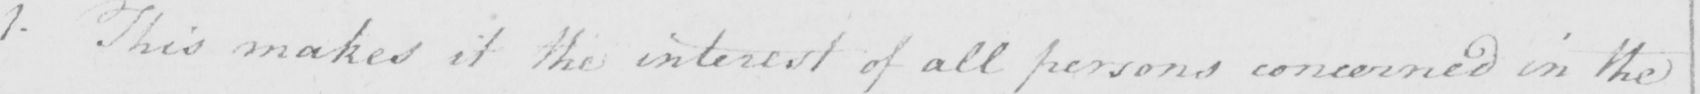Can you tell me what this handwritten text says? 1. This makes it the interest of all persons concerned in the 